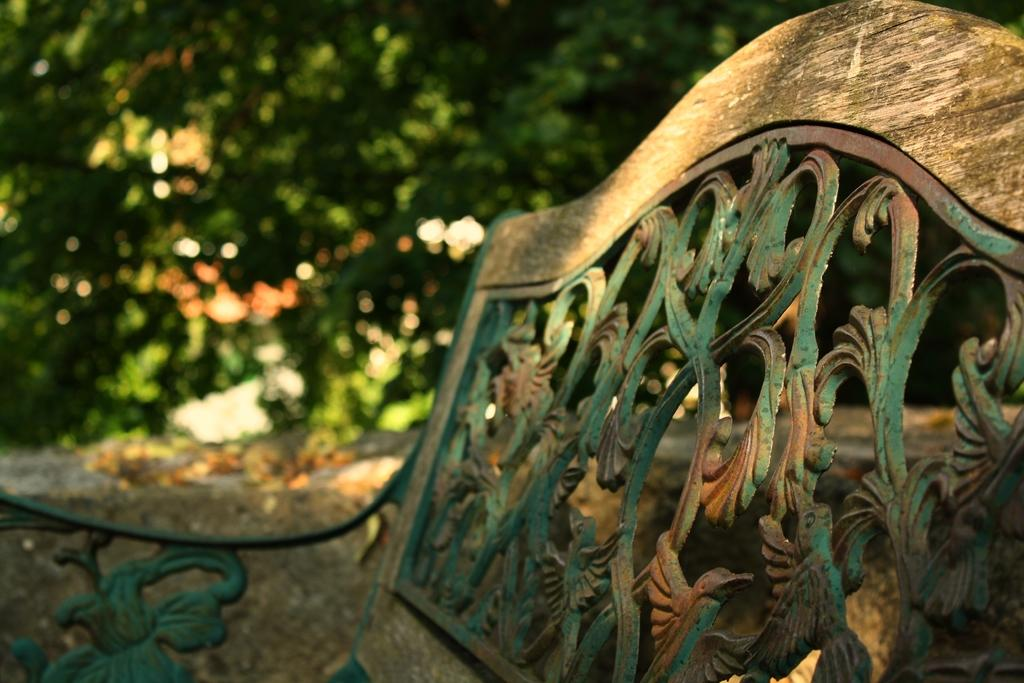What type of furniture is present in the image? There is a bench in the image. Can you describe the bench's appearance? The bench has a design. What can be seen in the background of the image? The background of the image is green and blurry. How many nuts are placed on the bench in the image? There are no nuts present in the image; it only features a bench with a design and a green, blurry background. 